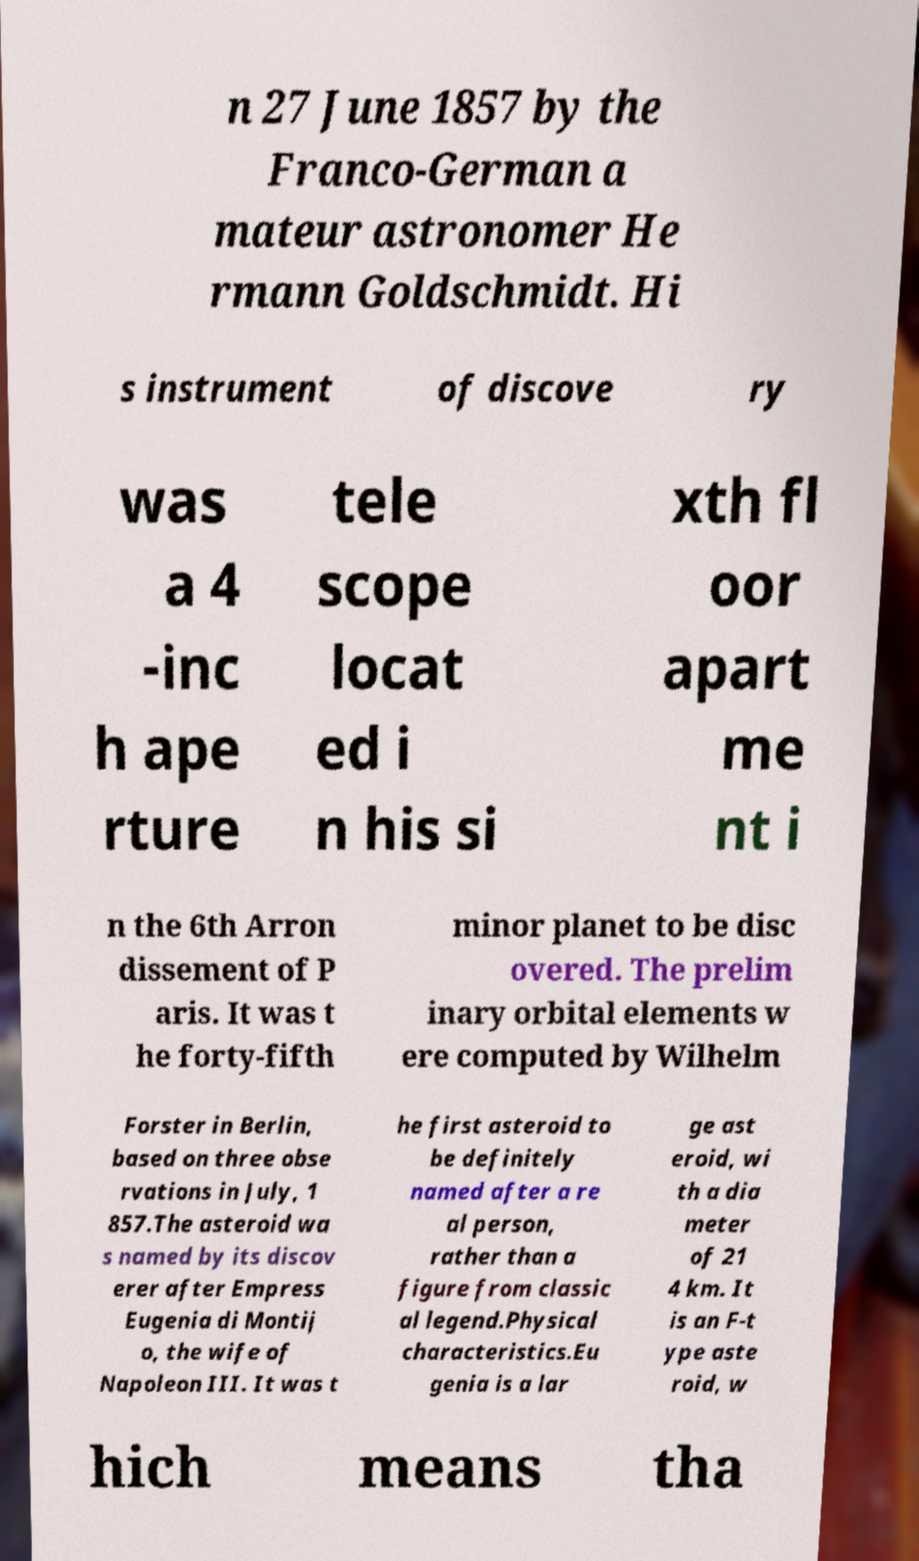Could you extract and type out the text from this image? n 27 June 1857 by the Franco-German a mateur astronomer He rmann Goldschmidt. Hi s instrument of discove ry was a 4 -inc h ape rture tele scope locat ed i n his si xth fl oor apart me nt i n the 6th Arron dissement of P aris. It was t he forty-fifth minor planet to be disc overed. The prelim inary orbital elements w ere computed by Wilhelm Forster in Berlin, based on three obse rvations in July, 1 857.The asteroid wa s named by its discov erer after Empress Eugenia di Montij o, the wife of Napoleon III. It was t he first asteroid to be definitely named after a re al person, rather than a figure from classic al legend.Physical characteristics.Eu genia is a lar ge ast eroid, wi th a dia meter of 21 4 km. It is an F-t ype aste roid, w hich means tha 